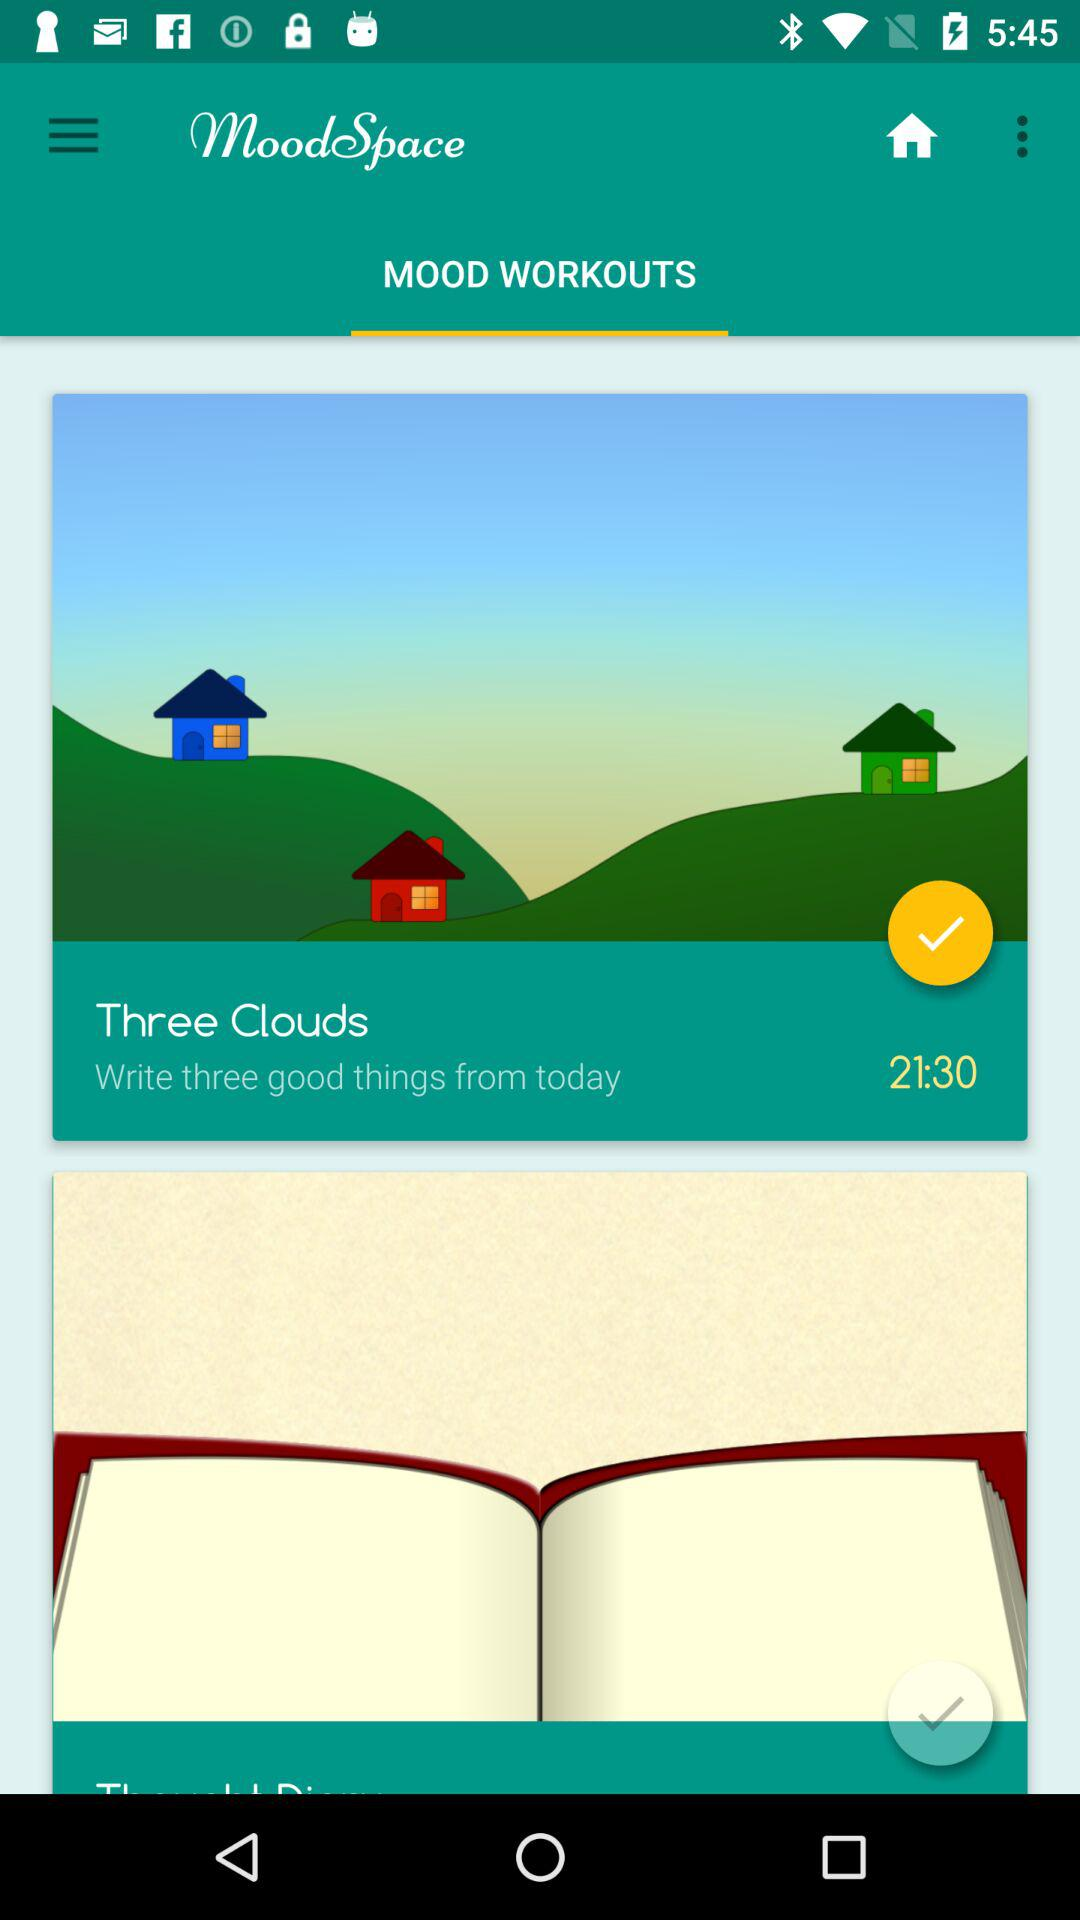What is the given time? The given time is 21:30. 